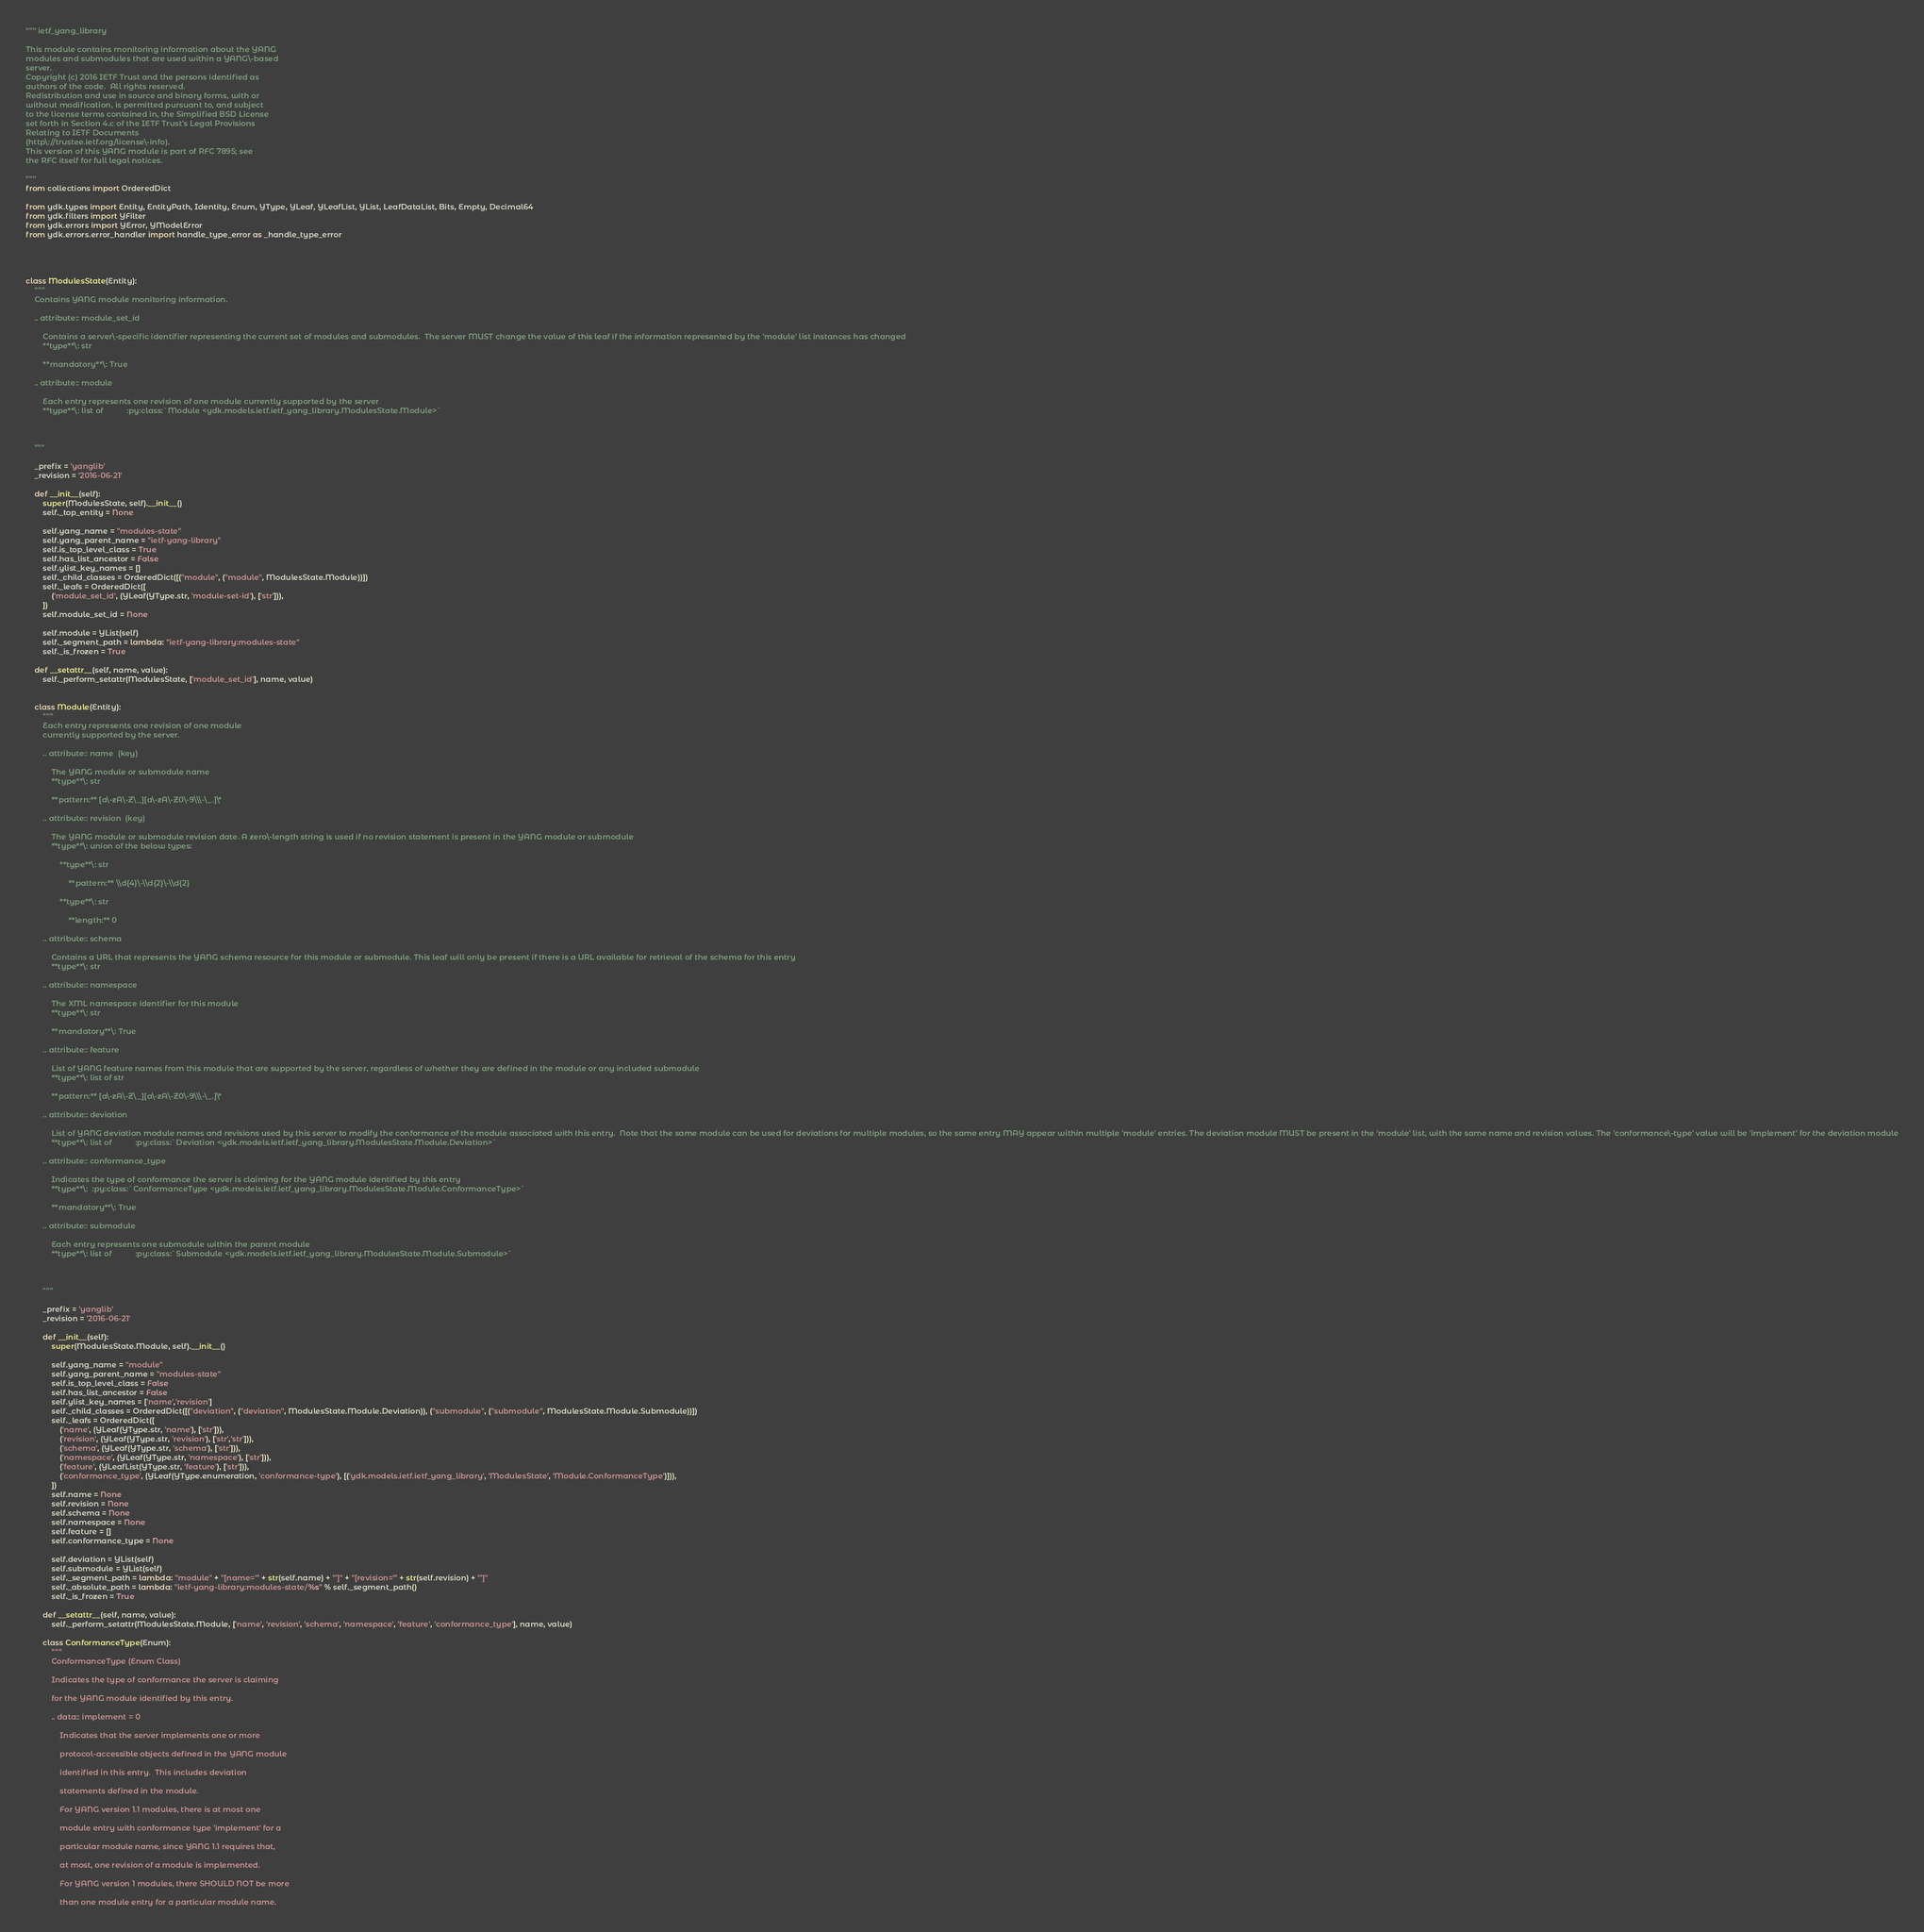<code> <loc_0><loc_0><loc_500><loc_500><_Python_>""" ietf_yang_library 

This module contains monitoring information about the YANG
modules and submodules that are used within a YANG\-based
server.
Copyright (c) 2016 IETF Trust and the persons identified as
authors of the code.  All rights reserved.
Redistribution and use in source and binary forms, with or
without modification, is permitted pursuant to, and subject
to the license terms contained in, the Simplified BSD License
set forth in Section 4.c of the IETF Trust's Legal Provisions
Relating to IETF Documents
(http\://trustee.ietf.org/license\-info).
This version of this YANG module is part of RFC 7895; see
the RFC itself for full legal notices.

"""
from collections import OrderedDict

from ydk.types import Entity, EntityPath, Identity, Enum, YType, YLeaf, YLeafList, YList, LeafDataList, Bits, Empty, Decimal64
from ydk.filters import YFilter
from ydk.errors import YError, YModelError
from ydk.errors.error_handler import handle_type_error as _handle_type_error




class ModulesState(Entity):
    """
    Contains YANG module monitoring information.
    
    .. attribute:: module_set_id
    
    	Contains a server\-specific identifier representing the current set of modules and submodules.  The server MUST change the value of this leaf if the information represented by the 'module' list instances has changed
    	**type**\: str
    
    	**mandatory**\: True
    
    .. attribute:: module
    
    	Each entry represents one revision of one module currently supported by the server
    	**type**\: list of  		 :py:class:`Module <ydk.models.ietf.ietf_yang_library.ModulesState.Module>`
    
    

    """

    _prefix = 'yanglib'
    _revision = '2016-06-21'

    def __init__(self):
        super(ModulesState, self).__init__()
        self._top_entity = None

        self.yang_name = "modules-state"
        self.yang_parent_name = "ietf-yang-library"
        self.is_top_level_class = True
        self.has_list_ancestor = False
        self.ylist_key_names = []
        self._child_classes = OrderedDict([("module", ("module", ModulesState.Module))])
        self._leafs = OrderedDict([
            ('module_set_id', (YLeaf(YType.str, 'module-set-id'), ['str'])),
        ])
        self.module_set_id = None

        self.module = YList(self)
        self._segment_path = lambda: "ietf-yang-library:modules-state"
        self._is_frozen = True

    def __setattr__(self, name, value):
        self._perform_setattr(ModulesState, ['module_set_id'], name, value)


    class Module(Entity):
        """
        Each entry represents one revision of one module
        currently supported by the server.
        
        .. attribute:: name  (key)
        
        	The YANG module or submodule name
        	**type**\: str
        
        	**pattern:** [a\-zA\-Z\_][a\-zA\-Z0\-9\\\-\_.]\*
        
        .. attribute:: revision  (key)
        
        	The YANG module or submodule revision date. A zero\-length string is used if no revision statement is present in the YANG module or submodule
        	**type**\: union of the below types:
        
        		**type**\: str
        
        			**pattern:** \\d{4}\-\\d{2}\-\\d{2}
        
        		**type**\: str
        
        			**length:** 0
        
        .. attribute:: schema
        
        	Contains a URL that represents the YANG schema resource for this module or submodule. This leaf will only be present if there is a URL available for retrieval of the schema for this entry
        	**type**\: str
        
        .. attribute:: namespace
        
        	The XML namespace identifier for this module
        	**type**\: str
        
        	**mandatory**\: True
        
        .. attribute:: feature
        
        	List of YANG feature names from this module that are supported by the server, regardless of whether they are defined in the module or any included submodule
        	**type**\: list of str
        
        	**pattern:** [a\-zA\-Z\_][a\-zA\-Z0\-9\\\-\_.]\*
        
        .. attribute:: deviation
        
        	List of YANG deviation module names and revisions used by this server to modify the conformance of the module associated with this entry.  Note that the same module can be used for deviations for multiple modules, so the same entry MAY appear within multiple 'module' entries. The deviation module MUST be present in the 'module' list, with the same name and revision values. The 'conformance\-type' value will be 'implement' for the deviation module
        	**type**\: list of  		 :py:class:`Deviation <ydk.models.ietf.ietf_yang_library.ModulesState.Module.Deviation>`
        
        .. attribute:: conformance_type
        
        	Indicates the type of conformance the server is claiming for the YANG module identified by this entry
        	**type**\:  :py:class:`ConformanceType <ydk.models.ietf.ietf_yang_library.ModulesState.Module.ConformanceType>`
        
        	**mandatory**\: True
        
        .. attribute:: submodule
        
        	Each entry represents one submodule within the parent module
        	**type**\: list of  		 :py:class:`Submodule <ydk.models.ietf.ietf_yang_library.ModulesState.Module.Submodule>`
        
        

        """

        _prefix = 'yanglib'
        _revision = '2016-06-21'

        def __init__(self):
            super(ModulesState.Module, self).__init__()

            self.yang_name = "module"
            self.yang_parent_name = "modules-state"
            self.is_top_level_class = False
            self.has_list_ancestor = False
            self.ylist_key_names = ['name','revision']
            self._child_classes = OrderedDict([("deviation", ("deviation", ModulesState.Module.Deviation)), ("submodule", ("submodule", ModulesState.Module.Submodule))])
            self._leafs = OrderedDict([
                ('name', (YLeaf(YType.str, 'name'), ['str'])),
                ('revision', (YLeaf(YType.str, 'revision'), ['str','str'])),
                ('schema', (YLeaf(YType.str, 'schema'), ['str'])),
                ('namespace', (YLeaf(YType.str, 'namespace'), ['str'])),
                ('feature', (YLeafList(YType.str, 'feature'), ['str'])),
                ('conformance_type', (YLeaf(YType.enumeration, 'conformance-type'), [('ydk.models.ietf.ietf_yang_library', 'ModulesState', 'Module.ConformanceType')])),
            ])
            self.name = None
            self.revision = None
            self.schema = None
            self.namespace = None
            self.feature = []
            self.conformance_type = None

            self.deviation = YList(self)
            self.submodule = YList(self)
            self._segment_path = lambda: "module" + "[name='" + str(self.name) + "']" + "[revision='" + str(self.revision) + "']"
            self._absolute_path = lambda: "ietf-yang-library:modules-state/%s" % self._segment_path()
            self._is_frozen = True

        def __setattr__(self, name, value):
            self._perform_setattr(ModulesState.Module, ['name', 'revision', 'schema', 'namespace', 'feature', 'conformance_type'], name, value)

        class ConformanceType(Enum):
            """
            ConformanceType (Enum Class)

            Indicates the type of conformance the server is claiming

            for the YANG module identified by this entry.

            .. data:: implement = 0

            	Indicates that the server implements one or more

            	protocol-accessible objects defined in the YANG module

            	identified in this entry.  This includes deviation

            	statements defined in the module.

            	For YANG version 1.1 modules, there is at most one

            	module entry with conformance type 'implement' for a

            	particular module name, since YANG 1.1 requires that,

            	at most, one revision of a module is implemented.

            	For YANG version 1 modules, there SHOULD NOT be more

            	than one module entry for a particular module name.
</code> 